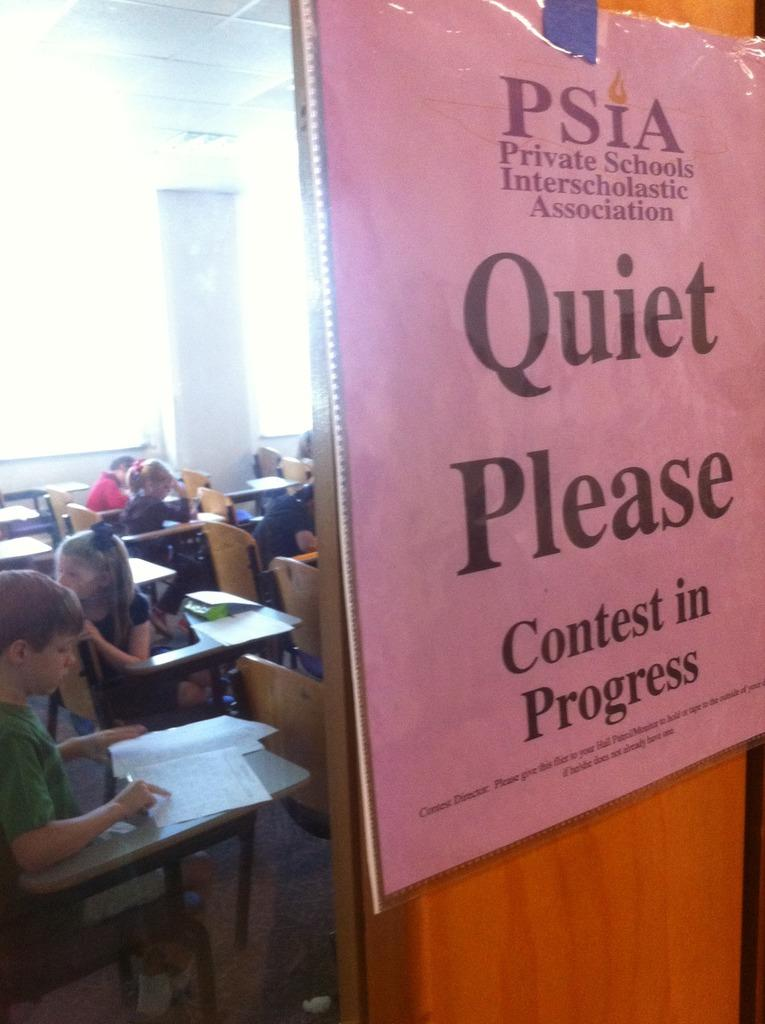<image>
Give a short and clear explanation of the subsequent image. Pink sign in front of a door which says Quiet Please. 